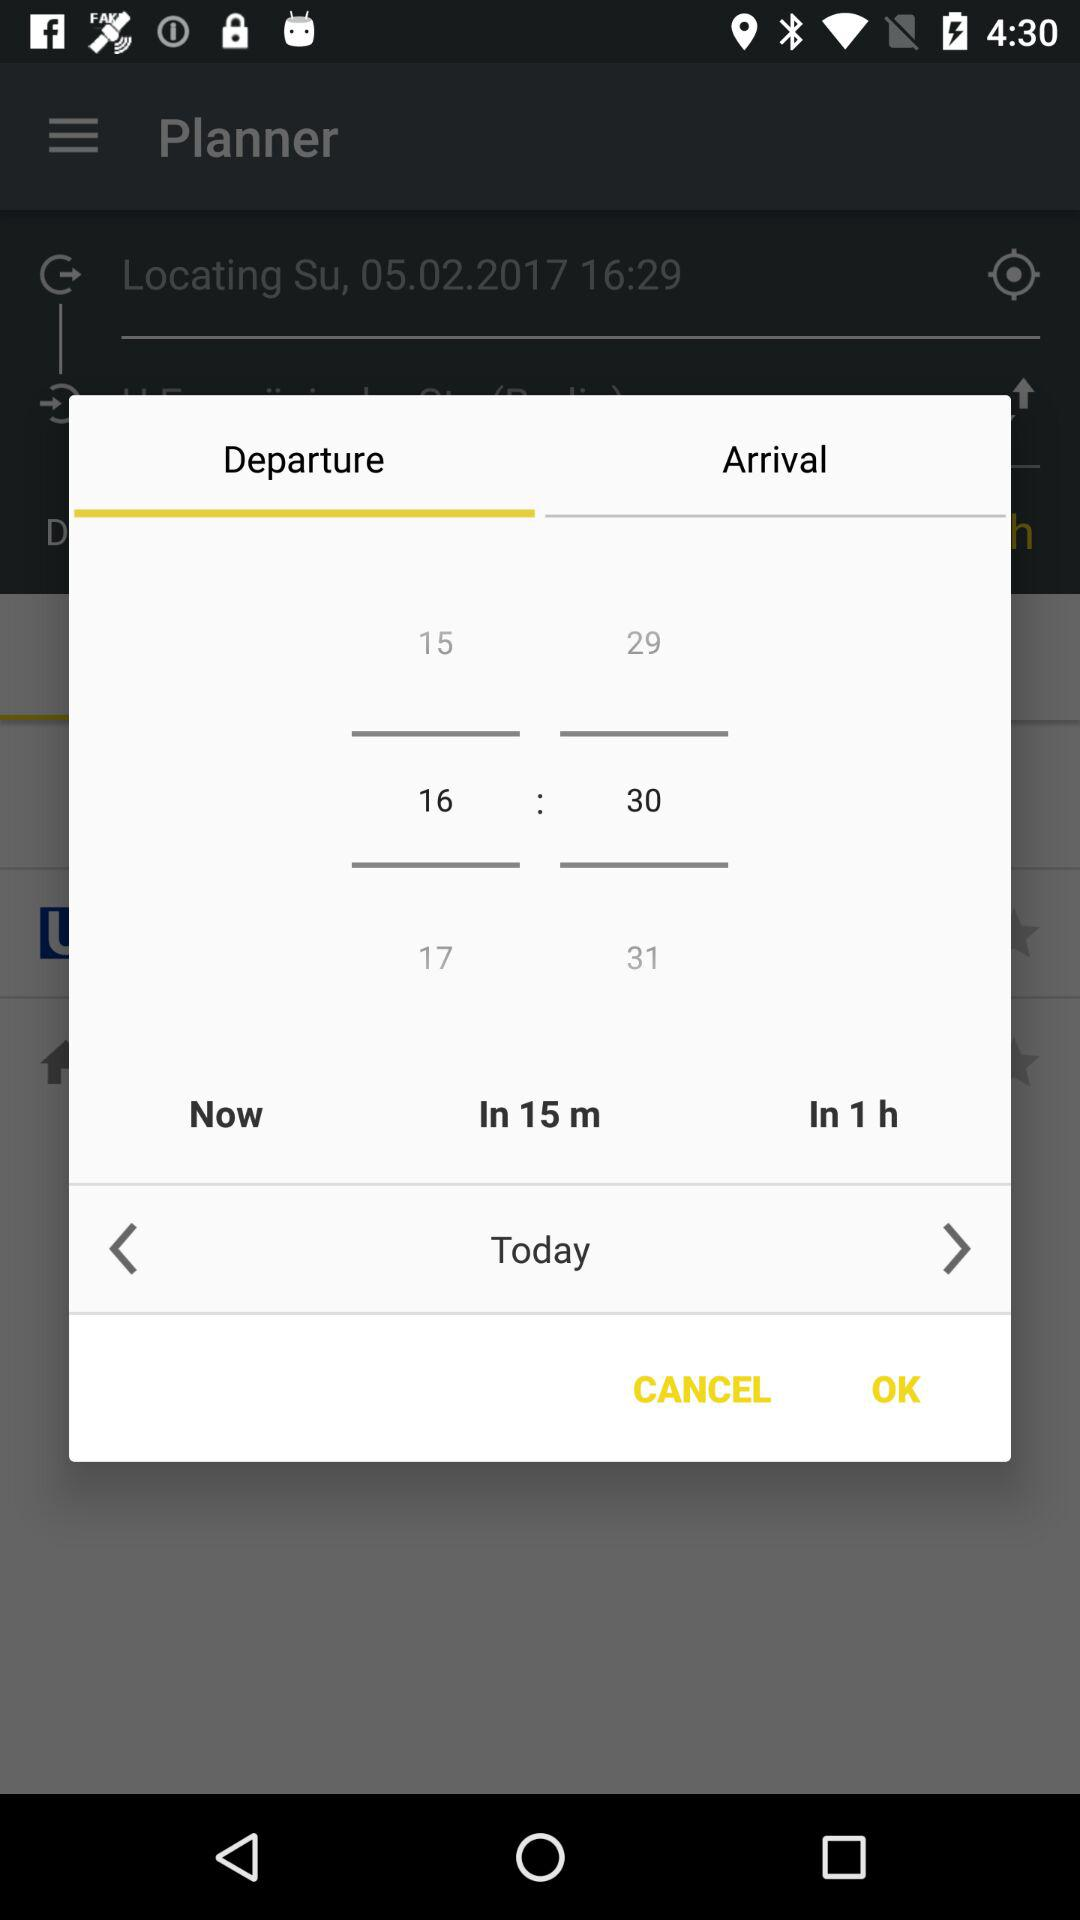What day is selected? The selected day is "Today". 